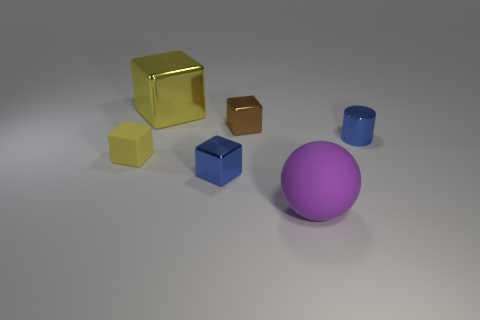There is a matte object on the left side of the large purple matte thing that is in front of the matte block; what is its color?
Your answer should be very brief. Yellow. What number of cyan objects are either metal things or metallic cubes?
Keep it short and to the point. 0. What color is the metallic object that is both right of the tiny blue shiny block and behind the blue cylinder?
Ensure brevity in your answer.  Brown. How many tiny objects are brown cubes or matte blocks?
Offer a terse response. 2. The yellow metallic object that is the same shape as the tiny brown shiny thing is what size?
Offer a terse response. Large. What is the shape of the purple thing?
Provide a succinct answer. Sphere. Is the material of the big yellow object the same as the object that is on the left side of the large metal object?
Your answer should be compact. No. How many shiny objects are either large purple balls or tiny blocks?
Offer a terse response. 2. There is a blue shiny thing that is in front of the small rubber cube; what size is it?
Keep it short and to the point. Small. There is a blue cube that is made of the same material as the small cylinder; what is its size?
Provide a short and direct response. Small. 